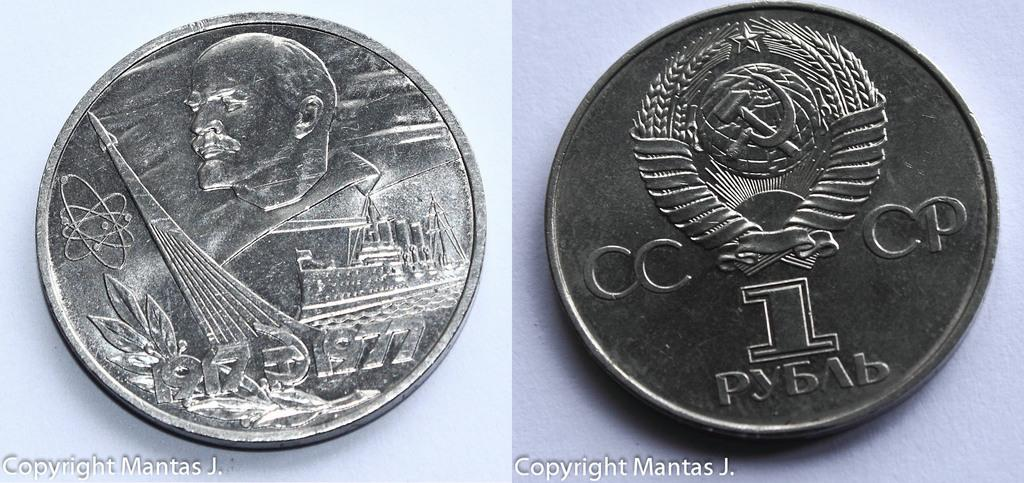<image>
Give a short and clear explanation of the subsequent image. Silver coins next to one another including one that says the number 1 on it. 